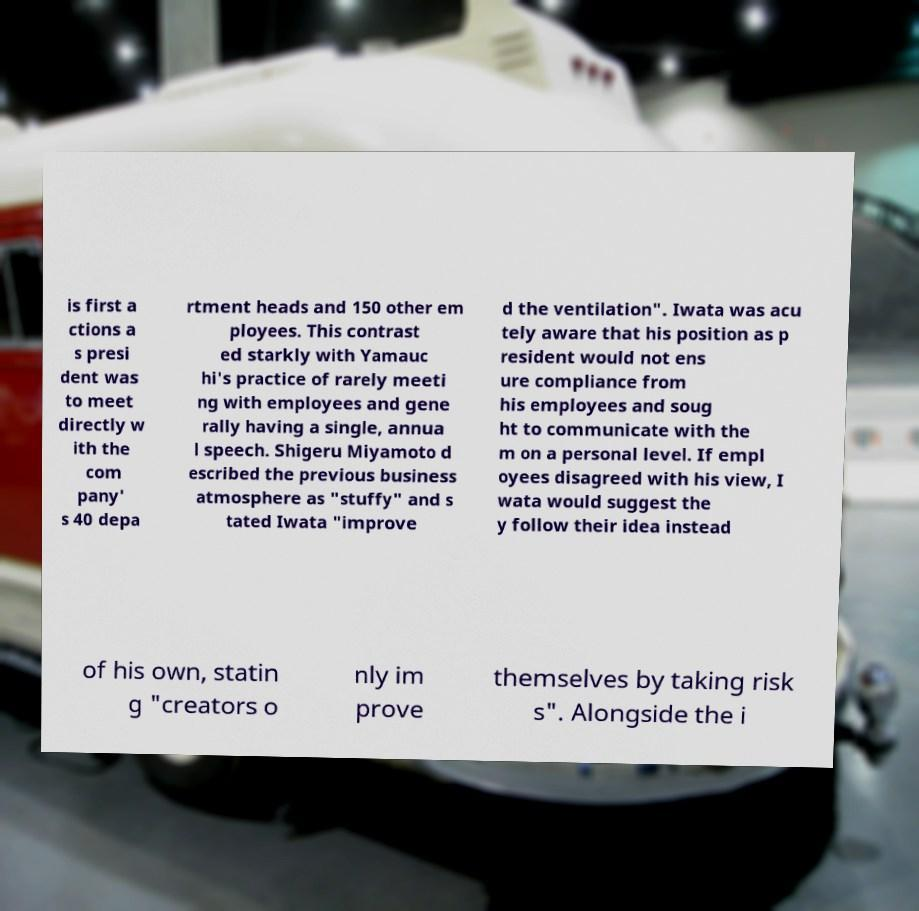There's text embedded in this image that I need extracted. Can you transcribe it verbatim? is first a ctions a s presi dent was to meet directly w ith the com pany' s 40 depa rtment heads and 150 other em ployees. This contrast ed starkly with Yamauc hi's practice of rarely meeti ng with employees and gene rally having a single, annua l speech. Shigeru Miyamoto d escribed the previous business atmosphere as "stuffy" and s tated Iwata "improve d the ventilation". Iwata was acu tely aware that his position as p resident would not ens ure compliance from his employees and soug ht to communicate with the m on a personal level. If empl oyees disagreed with his view, I wata would suggest the y follow their idea instead of his own, statin g "creators o nly im prove themselves by taking risk s". Alongside the i 